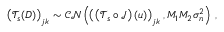Convert formula to latex. <formula><loc_0><loc_0><loc_500><loc_500>\left ( \mathcal { T } _ { s } ( D ) \right ) _ { j k } \sim \mathcal { C N } \left ( \left ( \left ( \mathcal { T } _ { s } \circ \mathcal { J } \right ) \left ( u \right ) \right ) _ { j k } , M _ { 1 } M _ { 2 } \sigma _ { n } ^ { 2 } \right ) \, ,</formula> 